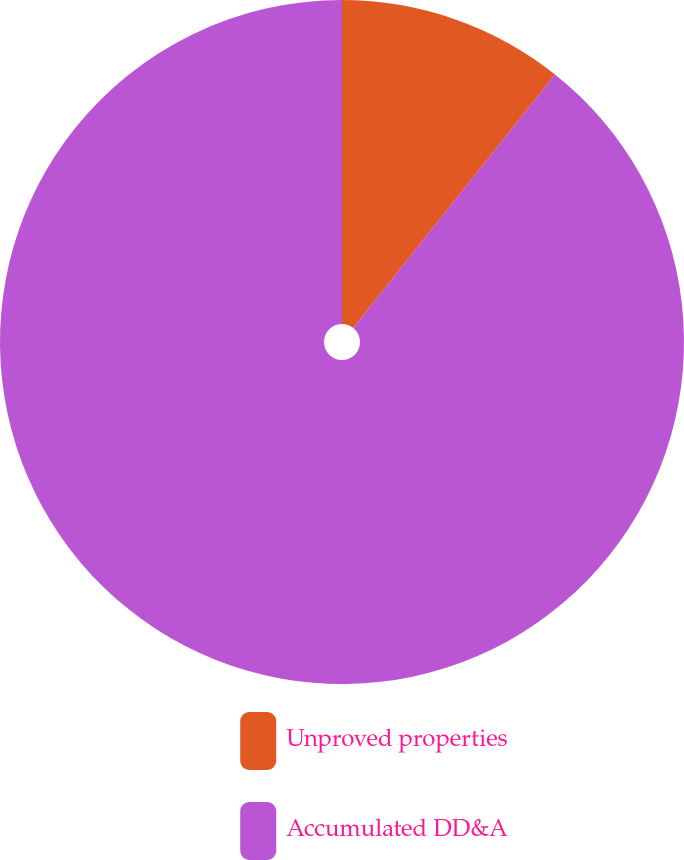Convert chart to OTSL. <chart><loc_0><loc_0><loc_500><loc_500><pie_chart><fcel>Unproved properties<fcel>Accumulated DD&A<nl><fcel>10.7%<fcel>89.3%<nl></chart> 